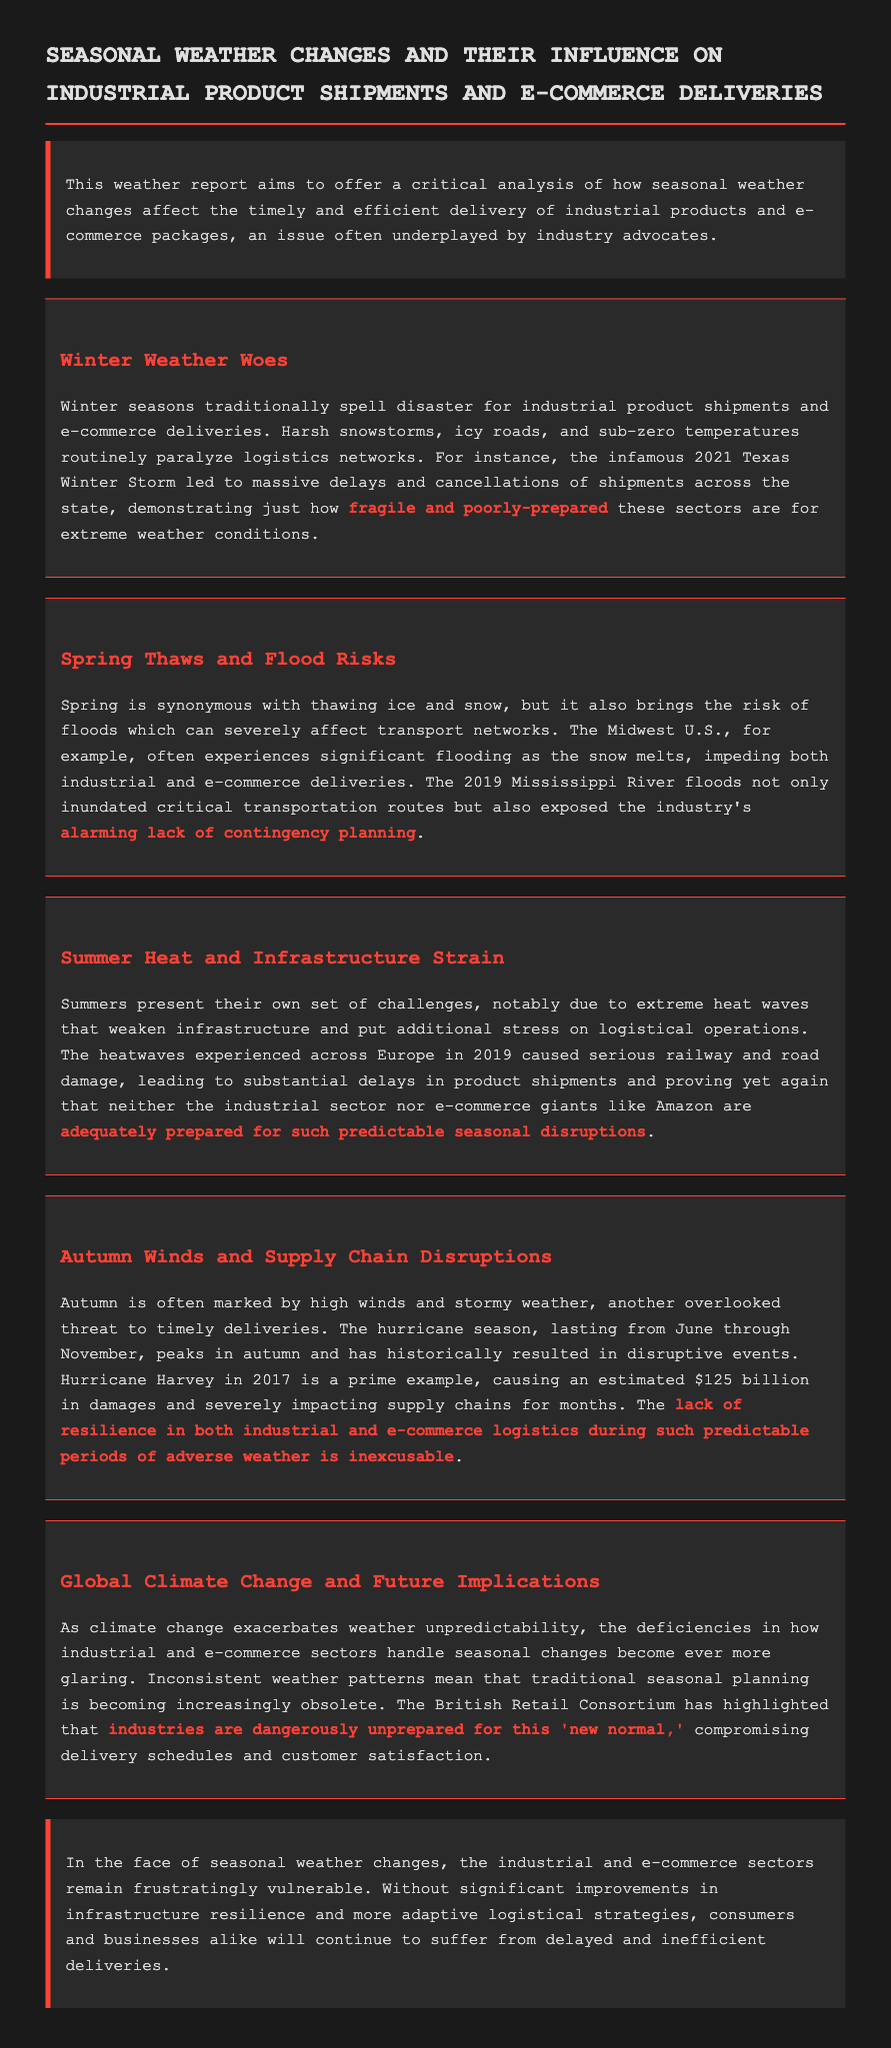What is the title of the report? The title is explicitly stated in the document at the top.
Answer: Seasonal Weather Changes and Their Influence on Industrial Product Shipments and E-commerce Deliveries What severe event caused massive delays in 2021? The document mentions a specific winter event affecting deliveries mentioned in the Winter Weather section.
Answer: Texas Winter Storm Which season is identified with thawing ice and flood risks? The Spring Thaws and Flood Risks section specifically discusses the effects of spring.
Answer: Spring What hurricane caused significant supply chain disruptions in 2017? The hurricane is referenced in the Autumn Winds and Supply Chain Disruptions section discussing its impacts.
Answer: Hurricane Harvey What major issue is highlighted regarding fall weather? The document emphasizes a specific problem related to seasonally changing weather patterns during autumn in the respective section.
Answer: High winds and stormy weather What is the "new normal" problem highlighted in the Global Climate Change section? The section notes the increasing unpredictability of weather patterns affecting industries.
Answer: Industries are dangerously unprepared 